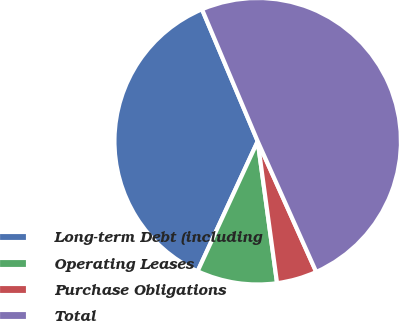Convert chart. <chart><loc_0><loc_0><loc_500><loc_500><pie_chart><fcel>Long-term Debt (including<fcel>Operating Leases<fcel>Purchase Obligations<fcel>Total<nl><fcel>36.75%<fcel>9.05%<fcel>4.54%<fcel>49.65%<nl></chart> 